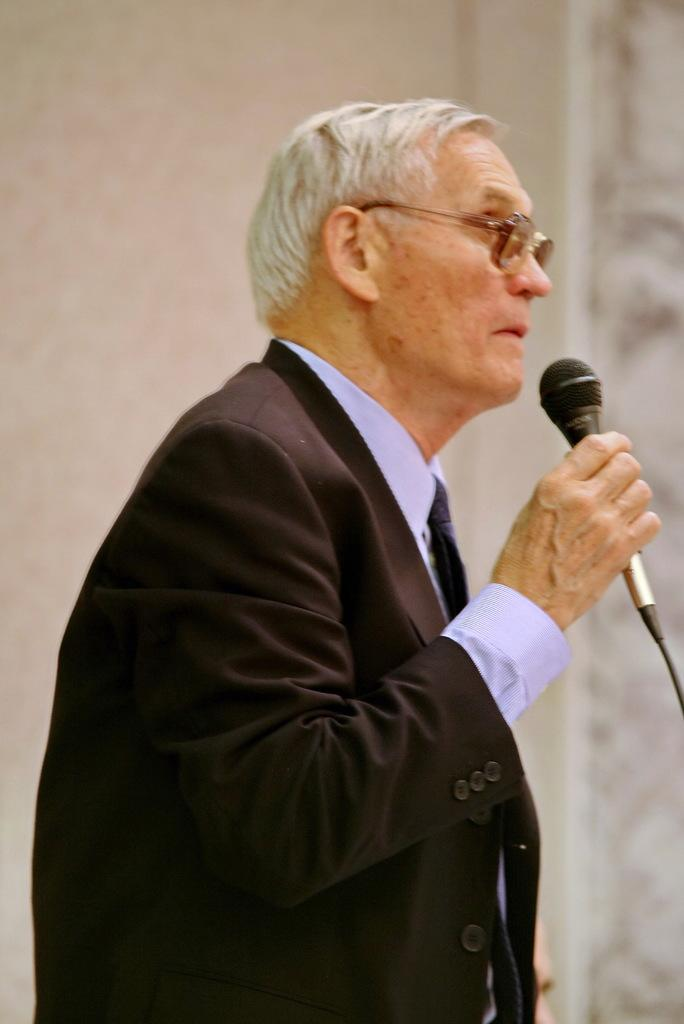What is the main subject of the image? There is a man in the image. What is the man doing in the image? The man is standing in the image. What object is the man holding in his hand? The man is holding a microphone in his hand. How many yaks can be seen in the image? There are no yaks present in the image. What type of parcel is the man holding in his hand? The man is not holding a parcel in his hand; he is holding a microphone. 